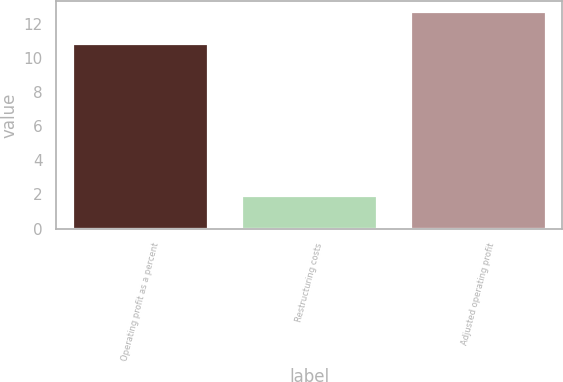Convert chart. <chart><loc_0><loc_0><loc_500><loc_500><bar_chart><fcel>Operating profit as a percent<fcel>Restructuring costs<fcel>Adjusted operating profit<nl><fcel>10.8<fcel>1.9<fcel>12.7<nl></chart> 